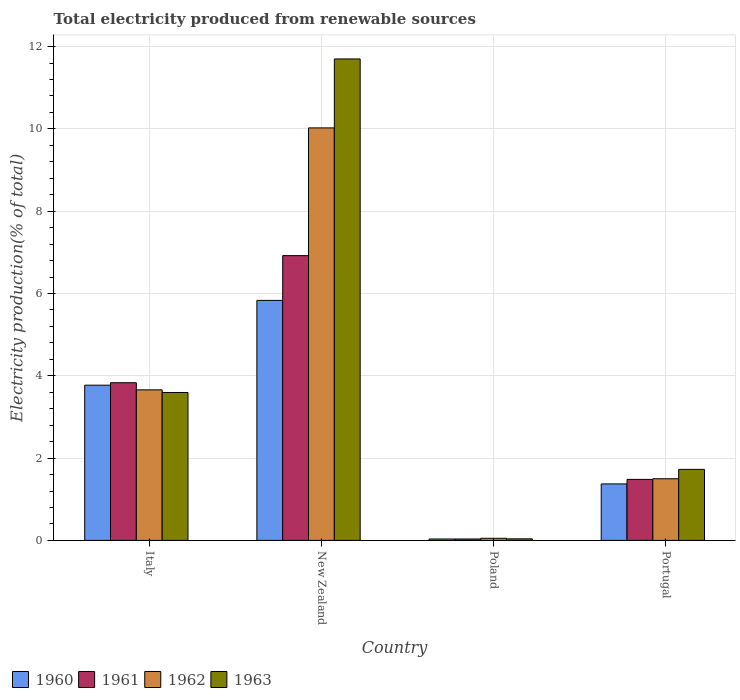Are the number of bars per tick equal to the number of legend labels?
Make the answer very short. Yes. How many bars are there on the 3rd tick from the left?
Offer a terse response. 4. What is the total electricity produced in 1962 in New Zealand?
Offer a terse response. 10.02. Across all countries, what is the maximum total electricity produced in 1960?
Give a very brief answer. 5.83. Across all countries, what is the minimum total electricity produced in 1960?
Keep it short and to the point. 0.03. In which country was the total electricity produced in 1960 maximum?
Ensure brevity in your answer.  New Zealand. In which country was the total electricity produced in 1961 minimum?
Offer a terse response. Poland. What is the total total electricity produced in 1961 in the graph?
Your answer should be compact. 12.27. What is the difference between the total electricity produced in 1961 in New Zealand and that in Portugal?
Provide a short and direct response. 5.44. What is the difference between the total electricity produced in 1963 in Portugal and the total electricity produced in 1960 in Italy?
Offer a terse response. -2.05. What is the average total electricity produced in 1960 per country?
Your answer should be very brief. 2.75. What is the difference between the total electricity produced of/in 1960 and total electricity produced of/in 1963 in New Zealand?
Provide a succinct answer. -5.87. In how many countries, is the total electricity produced in 1961 greater than 3.6 %?
Offer a very short reply. 2. What is the ratio of the total electricity produced in 1963 in Italy to that in New Zealand?
Provide a succinct answer. 0.31. Is the difference between the total electricity produced in 1960 in Italy and Poland greater than the difference between the total electricity produced in 1963 in Italy and Poland?
Make the answer very short. Yes. What is the difference between the highest and the second highest total electricity produced in 1962?
Your answer should be compact. -8.53. What is the difference between the highest and the lowest total electricity produced in 1962?
Make the answer very short. 9.97. Is the sum of the total electricity produced in 1961 in Italy and Portugal greater than the maximum total electricity produced in 1963 across all countries?
Offer a very short reply. No. Is it the case that in every country, the sum of the total electricity produced in 1960 and total electricity produced in 1961 is greater than the sum of total electricity produced in 1963 and total electricity produced in 1962?
Offer a very short reply. No. Is it the case that in every country, the sum of the total electricity produced in 1963 and total electricity produced in 1961 is greater than the total electricity produced in 1960?
Give a very brief answer. Yes. How many bars are there?
Your answer should be very brief. 16. Are all the bars in the graph horizontal?
Provide a short and direct response. No. How many countries are there in the graph?
Your answer should be compact. 4. Are the values on the major ticks of Y-axis written in scientific E-notation?
Your answer should be compact. No. Does the graph contain grids?
Your answer should be very brief. Yes. How many legend labels are there?
Offer a very short reply. 4. What is the title of the graph?
Provide a succinct answer. Total electricity produced from renewable sources. What is the label or title of the Y-axis?
Provide a short and direct response. Electricity production(% of total). What is the Electricity production(% of total) in 1960 in Italy?
Ensure brevity in your answer.  3.77. What is the Electricity production(% of total) of 1961 in Italy?
Offer a very short reply. 3.83. What is the Electricity production(% of total) in 1962 in Italy?
Give a very brief answer. 3.66. What is the Electricity production(% of total) of 1963 in Italy?
Your response must be concise. 3.59. What is the Electricity production(% of total) of 1960 in New Zealand?
Your answer should be very brief. 5.83. What is the Electricity production(% of total) in 1961 in New Zealand?
Provide a succinct answer. 6.92. What is the Electricity production(% of total) of 1962 in New Zealand?
Offer a very short reply. 10.02. What is the Electricity production(% of total) of 1963 in New Zealand?
Offer a very short reply. 11.7. What is the Electricity production(% of total) of 1960 in Poland?
Provide a succinct answer. 0.03. What is the Electricity production(% of total) of 1961 in Poland?
Give a very brief answer. 0.03. What is the Electricity production(% of total) of 1962 in Poland?
Make the answer very short. 0.05. What is the Electricity production(% of total) of 1963 in Poland?
Your answer should be compact. 0.04. What is the Electricity production(% of total) in 1960 in Portugal?
Give a very brief answer. 1.37. What is the Electricity production(% of total) of 1961 in Portugal?
Offer a terse response. 1.48. What is the Electricity production(% of total) of 1962 in Portugal?
Make the answer very short. 1.5. What is the Electricity production(% of total) of 1963 in Portugal?
Your response must be concise. 1.73. Across all countries, what is the maximum Electricity production(% of total) of 1960?
Provide a succinct answer. 5.83. Across all countries, what is the maximum Electricity production(% of total) in 1961?
Make the answer very short. 6.92. Across all countries, what is the maximum Electricity production(% of total) in 1962?
Your answer should be very brief. 10.02. Across all countries, what is the maximum Electricity production(% of total) of 1963?
Provide a short and direct response. 11.7. Across all countries, what is the minimum Electricity production(% of total) of 1960?
Your answer should be very brief. 0.03. Across all countries, what is the minimum Electricity production(% of total) in 1961?
Provide a succinct answer. 0.03. Across all countries, what is the minimum Electricity production(% of total) in 1962?
Offer a very short reply. 0.05. Across all countries, what is the minimum Electricity production(% of total) of 1963?
Your response must be concise. 0.04. What is the total Electricity production(% of total) of 1960 in the graph?
Ensure brevity in your answer.  11.01. What is the total Electricity production(% of total) of 1961 in the graph?
Make the answer very short. 12.27. What is the total Electricity production(% of total) of 1962 in the graph?
Your answer should be compact. 15.23. What is the total Electricity production(% of total) in 1963 in the graph?
Offer a terse response. 17.06. What is the difference between the Electricity production(% of total) in 1960 in Italy and that in New Zealand?
Your answer should be very brief. -2.06. What is the difference between the Electricity production(% of total) in 1961 in Italy and that in New Zealand?
Provide a succinct answer. -3.09. What is the difference between the Electricity production(% of total) in 1962 in Italy and that in New Zealand?
Give a very brief answer. -6.37. What is the difference between the Electricity production(% of total) of 1963 in Italy and that in New Zealand?
Offer a terse response. -8.11. What is the difference between the Electricity production(% of total) of 1960 in Italy and that in Poland?
Give a very brief answer. 3.74. What is the difference between the Electricity production(% of total) in 1961 in Italy and that in Poland?
Provide a short and direct response. 3.8. What is the difference between the Electricity production(% of total) in 1962 in Italy and that in Poland?
Give a very brief answer. 3.61. What is the difference between the Electricity production(% of total) of 1963 in Italy and that in Poland?
Make the answer very short. 3.56. What is the difference between the Electricity production(% of total) in 1960 in Italy and that in Portugal?
Your response must be concise. 2.4. What is the difference between the Electricity production(% of total) in 1961 in Italy and that in Portugal?
Provide a succinct answer. 2.35. What is the difference between the Electricity production(% of total) of 1962 in Italy and that in Portugal?
Offer a very short reply. 2.16. What is the difference between the Electricity production(% of total) in 1963 in Italy and that in Portugal?
Provide a succinct answer. 1.87. What is the difference between the Electricity production(% of total) in 1960 in New Zealand and that in Poland?
Ensure brevity in your answer.  5.8. What is the difference between the Electricity production(% of total) in 1961 in New Zealand and that in Poland?
Provide a short and direct response. 6.89. What is the difference between the Electricity production(% of total) of 1962 in New Zealand and that in Poland?
Ensure brevity in your answer.  9.97. What is the difference between the Electricity production(% of total) in 1963 in New Zealand and that in Poland?
Offer a very short reply. 11.66. What is the difference between the Electricity production(% of total) in 1960 in New Zealand and that in Portugal?
Provide a succinct answer. 4.46. What is the difference between the Electricity production(% of total) in 1961 in New Zealand and that in Portugal?
Offer a very short reply. 5.44. What is the difference between the Electricity production(% of total) in 1962 in New Zealand and that in Portugal?
Provide a short and direct response. 8.53. What is the difference between the Electricity production(% of total) in 1963 in New Zealand and that in Portugal?
Keep it short and to the point. 9.97. What is the difference between the Electricity production(% of total) of 1960 in Poland and that in Portugal?
Offer a terse response. -1.34. What is the difference between the Electricity production(% of total) in 1961 in Poland and that in Portugal?
Your answer should be compact. -1.45. What is the difference between the Electricity production(% of total) in 1962 in Poland and that in Portugal?
Keep it short and to the point. -1.45. What is the difference between the Electricity production(% of total) of 1963 in Poland and that in Portugal?
Provide a short and direct response. -1.69. What is the difference between the Electricity production(% of total) of 1960 in Italy and the Electricity production(% of total) of 1961 in New Zealand?
Keep it short and to the point. -3.15. What is the difference between the Electricity production(% of total) in 1960 in Italy and the Electricity production(% of total) in 1962 in New Zealand?
Provide a succinct answer. -6.25. What is the difference between the Electricity production(% of total) of 1960 in Italy and the Electricity production(% of total) of 1963 in New Zealand?
Your answer should be compact. -7.93. What is the difference between the Electricity production(% of total) in 1961 in Italy and the Electricity production(% of total) in 1962 in New Zealand?
Offer a very short reply. -6.19. What is the difference between the Electricity production(% of total) in 1961 in Italy and the Electricity production(% of total) in 1963 in New Zealand?
Provide a short and direct response. -7.87. What is the difference between the Electricity production(% of total) of 1962 in Italy and the Electricity production(% of total) of 1963 in New Zealand?
Provide a succinct answer. -8.04. What is the difference between the Electricity production(% of total) of 1960 in Italy and the Electricity production(% of total) of 1961 in Poland?
Provide a short and direct response. 3.74. What is the difference between the Electricity production(% of total) in 1960 in Italy and the Electricity production(% of total) in 1962 in Poland?
Offer a terse response. 3.72. What is the difference between the Electricity production(% of total) in 1960 in Italy and the Electricity production(% of total) in 1963 in Poland?
Your answer should be compact. 3.73. What is the difference between the Electricity production(% of total) in 1961 in Italy and the Electricity production(% of total) in 1962 in Poland?
Give a very brief answer. 3.78. What is the difference between the Electricity production(% of total) in 1961 in Italy and the Electricity production(% of total) in 1963 in Poland?
Give a very brief answer. 3.79. What is the difference between the Electricity production(% of total) in 1962 in Italy and the Electricity production(% of total) in 1963 in Poland?
Provide a succinct answer. 3.62. What is the difference between the Electricity production(% of total) of 1960 in Italy and the Electricity production(% of total) of 1961 in Portugal?
Offer a very short reply. 2.29. What is the difference between the Electricity production(% of total) in 1960 in Italy and the Electricity production(% of total) in 1962 in Portugal?
Keep it short and to the point. 2.27. What is the difference between the Electricity production(% of total) in 1960 in Italy and the Electricity production(% of total) in 1963 in Portugal?
Your response must be concise. 2.05. What is the difference between the Electricity production(% of total) in 1961 in Italy and the Electricity production(% of total) in 1962 in Portugal?
Provide a short and direct response. 2.33. What is the difference between the Electricity production(% of total) in 1961 in Italy and the Electricity production(% of total) in 1963 in Portugal?
Offer a terse response. 2.11. What is the difference between the Electricity production(% of total) of 1962 in Italy and the Electricity production(% of total) of 1963 in Portugal?
Ensure brevity in your answer.  1.93. What is the difference between the Electricity production(% of total) in 1960 in New Zealand and the Electricity production(% of total) in 1961 in Poland?
Offer a very short reply. 5.8. What is the difference between the Electricity production(% of total) of 1960 in New Zealand and the Electricity production(% of total) of 1962 in Poland?
Give a very brief answer. 5.78. What is the difference between the Electricity production(% of total) of 1960 in New Zealand and the Electricity production(% of total) of 1963 in Poland?
Give a very brief answer. 5.79. What is the difference between the Electricity production(% of total) in 1961 in New Zealand and the Electricity production(% of total) in 1962 in Poland?
Keep it short and to the point. 6.87. What is the difference between the Electricity production(% of total) of 1961 in New Zealand and the Electricity production(% of total) of 1963 in Poland?
Give a very brief answer. 6.88. What is the difference between the Electricity production(% of total) of 1962 in New Zealand and the Electricity production(% of total) of 1963 in Poland?
Your response must be concise. 9.99. What is the difference between the Electricity production(% of total) of 1960 in New Zealand and the Electricity production(% of total) of 1961 in Portugal?
Give a very brief answer. 4.35. What is the difference between the Electricity production(% of total) in 1960 in New Zealand and the Electricity production(% of total) in 1962 in Portugal?
Your answer should be very brief. 4.33. What is the difference between the Electricity production(% of total) of 1960 in New Zealand and the Electricity production(% of total) of 1963 in Portugal?
Give a very brief answer. 4.11. What is the difference between the Electricity production(% of total) of 1961 in New Zealand and the Electricity production(% of total) of 1962 in Portugal?
Keep it short and to the point. 5.42. What is the difference between the Electricity production(% of total) of 1961 in New Zealand and the Electricity production(% of total) of 1963 in Portugal?
Provide a short and direct response. 5.19. What is the difference between the Electricity production(% of total) of 1962 in New Zealand and the Electricity production(% of total) of 1963 in Portugal?
Make the answer very short. 8.3. What is the difference between the Electricity production(% of total) of 1960 in Poland and the Electricity production(% of total) of 1961 in Portugal?
Provide a short and direct response. -1.45. What is the difference between the Electricity production(% of total) in 1960 in Poland and the Electricity production(% of total) in 1962 in Portugal?
Keep it short and to the point. -1.46. What is the difference between the Electricity production(% of total) of 1960 in Poland and the Electricity production(% of total) of 1963 in Portugal?
Ensure brevity in your answer.  -1.69. What is the difference between the Electricity production(% of total) of 1961 in Poland and the Electricity production(% of total) of 1962 in Portugal?
Offer a very short reply. -1.46. What is the difference between the Electricity production(% of total) in 1961 in Poland and the Electricity production(% of total) in 1963 in Portugal?
Your answer should be compact. -1.69. What is the difference between the Electricity production(% of total) in 1962 in Poland and the Electricity production(% of total) in 1963 in Portugal?
Your answer should be compact. -1.67. What is the average Electricity production(% of total) of 1960 per country?
Your response must be concise. 2.75. What is the average Electricity production(% of total) in 1961 per country?
Your answer should be very brief. 3.07. What is the average Electricity production(% of total) of 1962 per country?
Your answer should be compact. 3.81. What is the average Electricity production(% of total) of 1963 per country?
Your response must be concise. 4.26. What is the difference between the Electricity production(% of total) in 1960 and Electricity production(% of total) in 1961 in Italy?
Offer a terse response. -0.06. What is the difference between the Electricity production(% of total) of 1960 and Electricity production(% of total) of 1962 in Italy?
Offer a terse response. 0.11. What is the difference between the Electricity production(% of total) in 1960 and Electricity production(% of total) in 1963 in Italy?
Give a very brief answer. 0.18. What is the difference between the Electricity production(% of total) in 1961 and Electricity production(% of total) in 1962 in Italy?
Give a very brief answer. 0.17. What is the difference between the Electricity production(% of total) of 1961 and Electricity production(% of total) of 1963 in Italy?
Offer a very short reply. 0.24. What is the difference between the Electricity production(% of total) of 1962 and Electricity production(% of total) of 1963 in Italy?
Make the answer very short. 0.06. What is the difference between the Electricity production(% of total) of 1960 and Electricity production(% of total) of 1961 in New Zealand?
Provide a succinct answer. -1.09. What is the difference between the Electricity production(% of total) of 1960 and Electricity production(% of total) of 1962 in New Zealand?
Offer a very short reply. -4.19. What is the difference between the Electricity production(% of total) of 1960 and Electricity production(% of total) of 1963 in New Zealand?
Provide a succinct answer. -5.87. What is the difference between the Electricity production(% of total) in 1961 and Electricity production(% of total) in 1962 in New Zealand?
Keep it short and to the point. -3.1. What is the difference between the Electricity production(% of total) of 1961 and Electricity production(% of total) of 1963 in New Zealand?
Provide a short and direct response. -4.78. What is the difference between the Electricity production(% of total) in 1962 and Electricity production(% of total) in 1963 in New Zealand?
Keep it short and to the point. -1.68. What is the difference between the Electricity production(% of total) of 1960 and Electricity production(% of total) of 1962 in Poland?
Offer a terse response. -0.02. What is the difference between the Electricity production(% of total) in 1960 and Electricity production(% of total) in 1963 in Poland?
Your answer should be very brief. -0. What is the difference between the Electricity production(% of total) of 1961 and Electricity production(% of total) of 1962 in Poland?
Give a very brief answer. -0.02. What is the difference between the Electricity production(% of total) in 1961 and Electricity production(% of total) in 1963 in Poland?
Your answer should be compact. -0. What is the difference between the Electricity production(% of total) in 1962 and Electricity production(% of total) in 1963 in Poland?
Keep it short and to the point. 0.01. What is the difference between the Electricity production(% of total) of 1960 and Electricity production(% of total) of 1961 in Portugal?
Offer a terse response. -0.11. What is the difference between the Electricity production(% of total) in 1960 and Electricity production(% of total) in 1962 in Portugal?
Your answer should be very brief. -0.13. What is the difference between the Electricity production(% of total) in 1960 and Electricity production(% of total) in 1963 in Portugal?
Your answer should be very brief. -0.35. What is the difference between the Electricity production(% of total) of 1961 and Electricity production(% of total) of 1962 in Portugal?
Ensure brevity in your answer.  -0.02. What is the difference between the Electricity production(% of total) of 1961 and Electricity production(% of total) of 1963 in Portugal?
Offer a terse response. -0.24. What is the difference between the Electricity production(% of total) of 1962 and Electricity production(% of total) of 1963 in Portugal?
Make the answer very short. -0.23. What is the ratio of the Electricity production(% of total) of 1960 in Italy to that in New Zealand?
Provide a succinct answer. 0.65. What is the ratio of the Electricity production(% of total) in 1961 in Italy to that in New Zealand?
Ensure brevity in your answer.  0.55. What is the ratio of the Electricity production(% of total) in 1962 in Italy to that in New Zealand?
Give a very brief answer. 0.36. What is the ratio of the Electricity production(% of total) of 1963 in Italy to that in New Zealand?
Offer a very short reply. 0.31. What is the ratio of the Electricity production(% of total) of 1960 in Italy to that in Poland?
Provide a succinct answer. 110.45. What is the ratio of the Electricity production(% of total) in 1961 in Italy to that in Poland?
Offer a very short reply. 112.3. What is the ratio of the Electricity production(% of total) of 1962 in Italy to that in Poland?
Your response must be concise. 71.88. What is the ratio of the Electricity production(% of total) of 1963 in Italy to that in Poland?
Offer a very short reply. 94.84. What is the ratio of the Electricity production(% of total) of 1960 in Italy to that in Portugal?
Give a very brief answer. 2.75. What is the ratio of the Electricity production(% of total) in 1961 in Italy to that in Portugal?
Your answer should be compact. 2.58. What is the ratio of the Electricity production(% of total) in 1962 in Italy to that in Portugal?
Your response must be concise. 2.44. What is the ratio of the Electricity production(% of total) in 1963 in Italy to that in Portugal?
Your answer should be compact. 2.08. What is the ratio of the Electricity production(% of total) in 1960 in New Zealand to that in Poland?
Your response must be concise. 170.79. What is the ratio of the Electricity production(% of total) of 1961 in New Zealand to that in Poland?
Your answer should be very brief. 202.83. What is the ratio of the Electricity production(% of total) in 1962 in New Zealand to that in Poland?
Your answer should be very brief. 196.95. What is the ratio of the Electricity production(% of total) of 1963 in New Zealand to that in Poland?
Your response must be concise. 308.73. What is the ratio of the Electricity production(% of total) of 1960 in New Zealand to that in Portugal?
Make the answer very short. 4.25. What is the ratio of the Electricity production(% of total) in 1961 in New Zealand to that in Portugal?
Provide a short and direct response. 4.67. What is the ratio of the Electricity production(% of total) in 1962 in New Zealand to that in Portugal?
Ensure brevity in your answer.  6.69. What is the ratio of the Electricity production(% of total) of 1963 in New Zealand to that in Portugal?
Keep it short and to the point. 6.78. What is the ratio of the Electricity production(% of total) in 1960 in Poland to that in Portugal?
Provide a succinct answer. 0.02. What is the ratio of the Electricity production(% of total) in 1961 in Poland to that in Portugal?
Make the answer very short. 0.02. What is the ratio of the Electricity production(% of total) in 1962 in Poland to that in Portugal?
Give a very brief answer. 0.03. What is the ratio of the Electricity production(% of total) of 1963 in Poland to that in Portugal?
Give a very brief answer. 0.02. What is the difference between the highest and the second highest Electricity production(% of total) of 1960?
Provide a succinct answer. 2.06. What is the difference between the highest and the second highest Electricity production(% of total) of 1961?
Give a very brief answer. 3.09. What is the difference between the highest and the second highest Electricity production(% of total) of 1962?
Your response must be concise. 6.37. What is the difference between the highest and the second highest Electricity production(% of total) in 1963?
Offer a terse response. 8.11. What is the difference between the highest and the lowest Electricity production(% of total) in 1960?
Provide a succinct answer. 5.8. What is the difference between the highest and the lowest Electricity production(% of total) in 1961?
Your response must be concise. 6.89. What is the difference between the highest and the lowest Electricity production(% of total) of 1962?
Your answer should be compact. 9.97. What is the difference between the highest and the lowest Electricity production(% of total) in 1963?
Offer a very short reply. 11.66. 